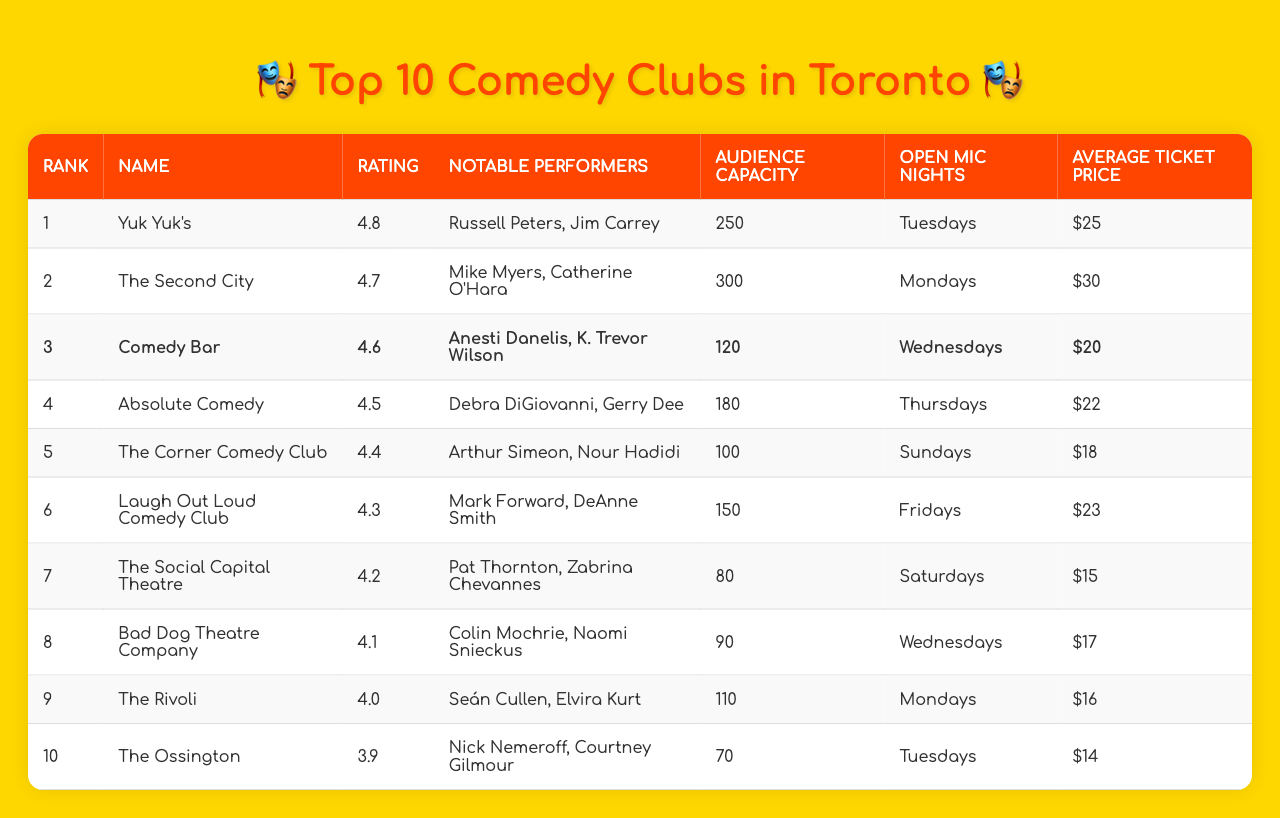What is the highest-rated comedy club in Toronto? The table shows that "Yuk Yuk's" has the highest rating of 4.8 among all the listed comedy clubs in Toronto.
Answer: Yuk Yuk's Which comedy club has the largest audience capacity? Looking at the audience capacity column, "The Second City" has the largest capacity at 300.
Answer: The Second City How many clubs have a rating above 4.5? From the ratings, "Yuk Yuk's", "The Second City", "Comedy Bar", and "Absolute Comedy" have ratings above 4.5, totaling 4 clubs.
Answer: 4 What are the average ticket prices for the top three highest-rated comedy clubs? The average can be calculated by adding the ticket prices of the top three clubs ($25 from Yuk Yuk's, $30 from The Second City, $20 from Comedy Bar) which totals $75 and then dividing by 3, resulting in an average price of $25.
Answer: $25 Do any clubs have open mic nights on Tuesdays? The table indicates that both "Yuk Yuk's" and "The Ossington" have open mic nights on Tuesdays, confirming that there are clubs with that schedule.
Answer: Yes Which club is listed as performing with Anesti Danelis? The club "Comedy Bar" features Anesti Danelis as one of its notable performers, according to the data.
Answer: Comedy Bar What is the average rating of all the clubs listed? To find the average, we add all the ratings (4.8 + 4.7 + 4.6 + 4.5 + 4.4 + 4.3 + 4.2 + 4.1 + 4.0 + 3.9 = 46.5) and divide by the number of clubs (10), yielding an average rating of 4.65.
Answer: 4.65 Is the average ticket price for "The Social Capital Theatre" higher than $15? The ticket price for "The Social Capital Theatre" is $15, which is not higher than $15.
Answer: No Which club has the lowest audience capacity and who are its notable performers? "The Ossington" has the lowest audience capacity at 70, and its notable performers are Nick Nemeroff and Courtney Gilmour.
Answer: The Ossington, Nick Nemeroff and Courtney Gilmour How many clubs have "Wednesdays" as their open mic nights? By checking the open mic nights, we see that "Comedy Bar" and "Bad Dog Theatre Company" both have "Wednesdays," resulting in a total of 2 clubs.
Answer: 2 